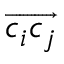Convert formula to latex. <formula><loc_0><loc_0><loc_500><loc_500>\overrightarrow { c _ { i } c _ { j } }</formula> 